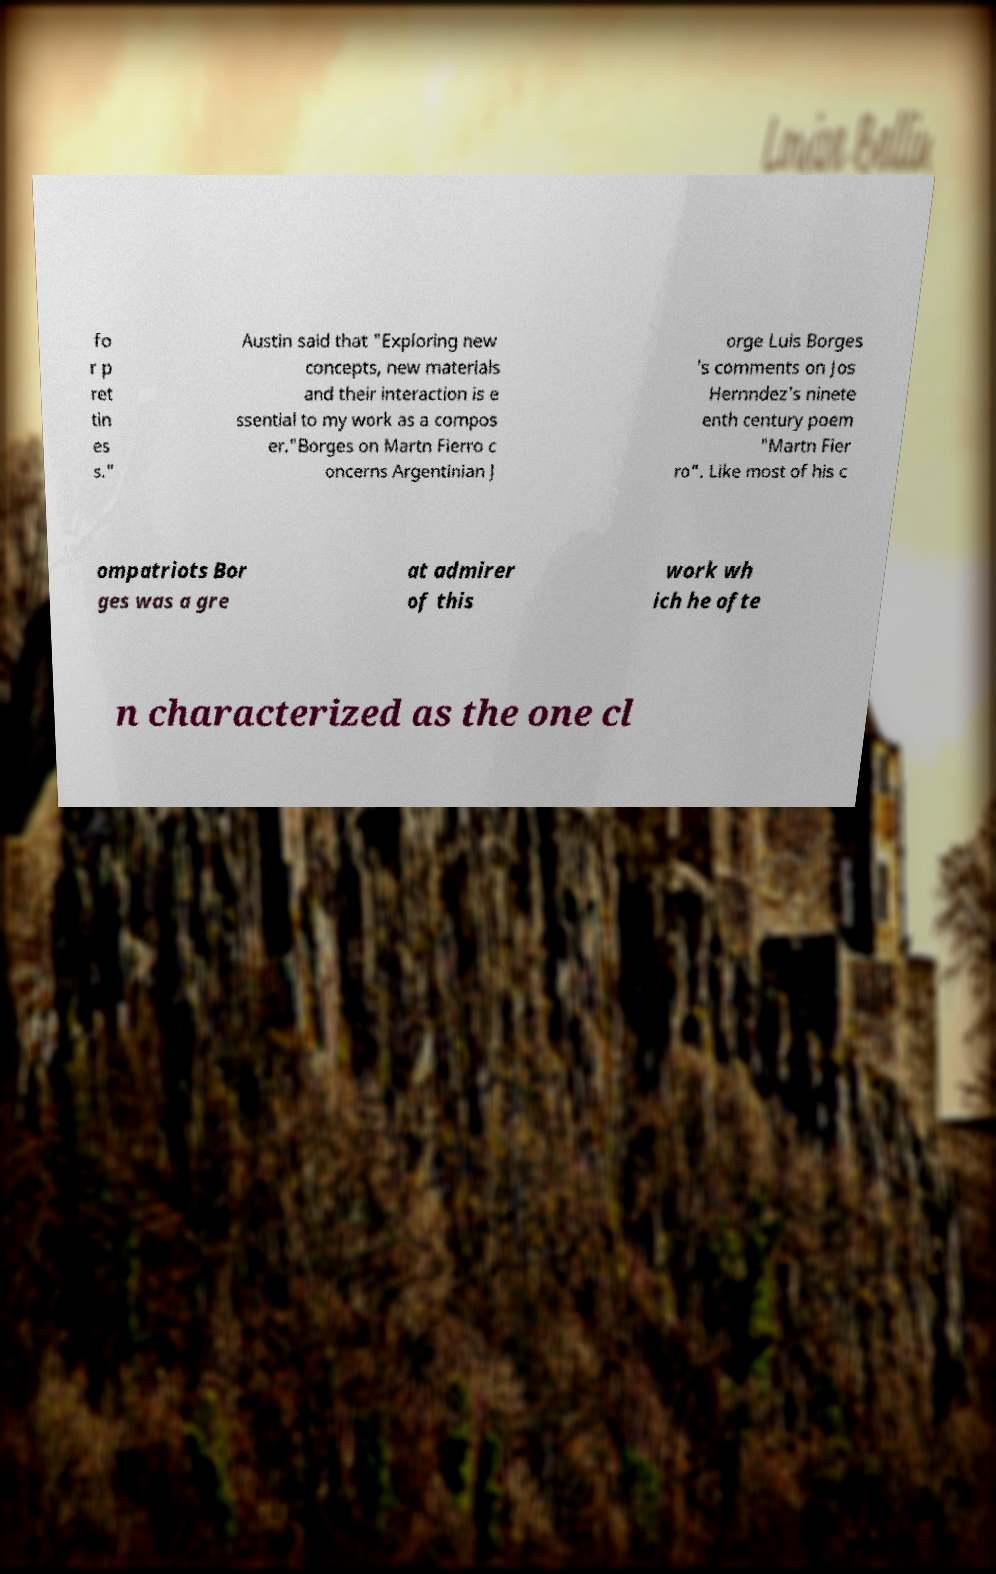For documentation purposes, I need the text within this image transcribed. Could you provide that? fo r p ret tin es s." Austin said that "Exploring new concepts, new materials and their interaction is e ssential to my work as a compos er."Borges on Martn Fierro c oncerns Argentinian J orge Luis Borges 's comments on Jos Hernndez's ninete enth century poem "Martn Fier ro". Like most of his c ompatriots Bor ges was a gre at admirer of this work wh ich he ofte n characterized as the one cl 